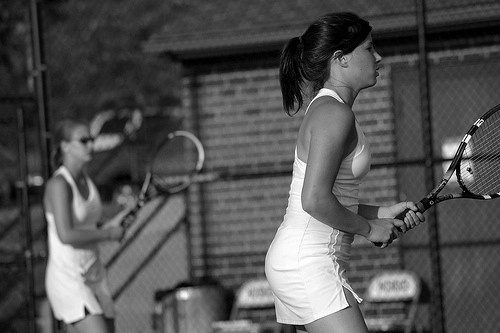Describe the objects in this image and their specific colors. I can see people in black, gray, lightgray, and darkgray tones, people in black, gray, darkgray, and lightgray tones, tennis racket in black, gray, darkgray, and lightgray tones, tennis racket in black, gray, darkgray, and lightgray tones, and chair in black, gray, darkgray, and lightgray tones in this image. 